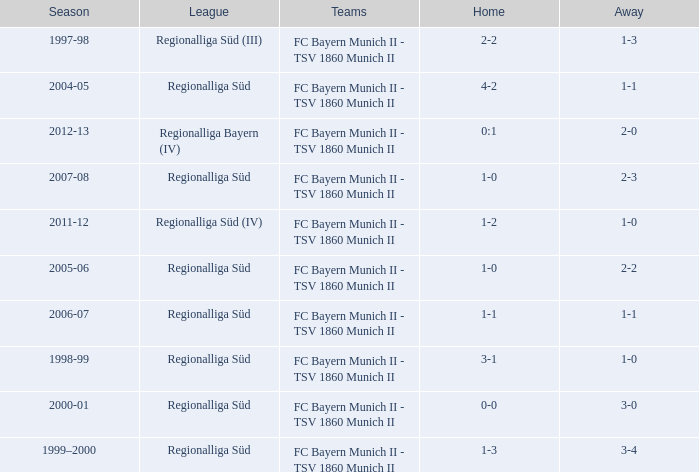What is the league with a 0:1 home? Regionalliga Bayern (IV). 